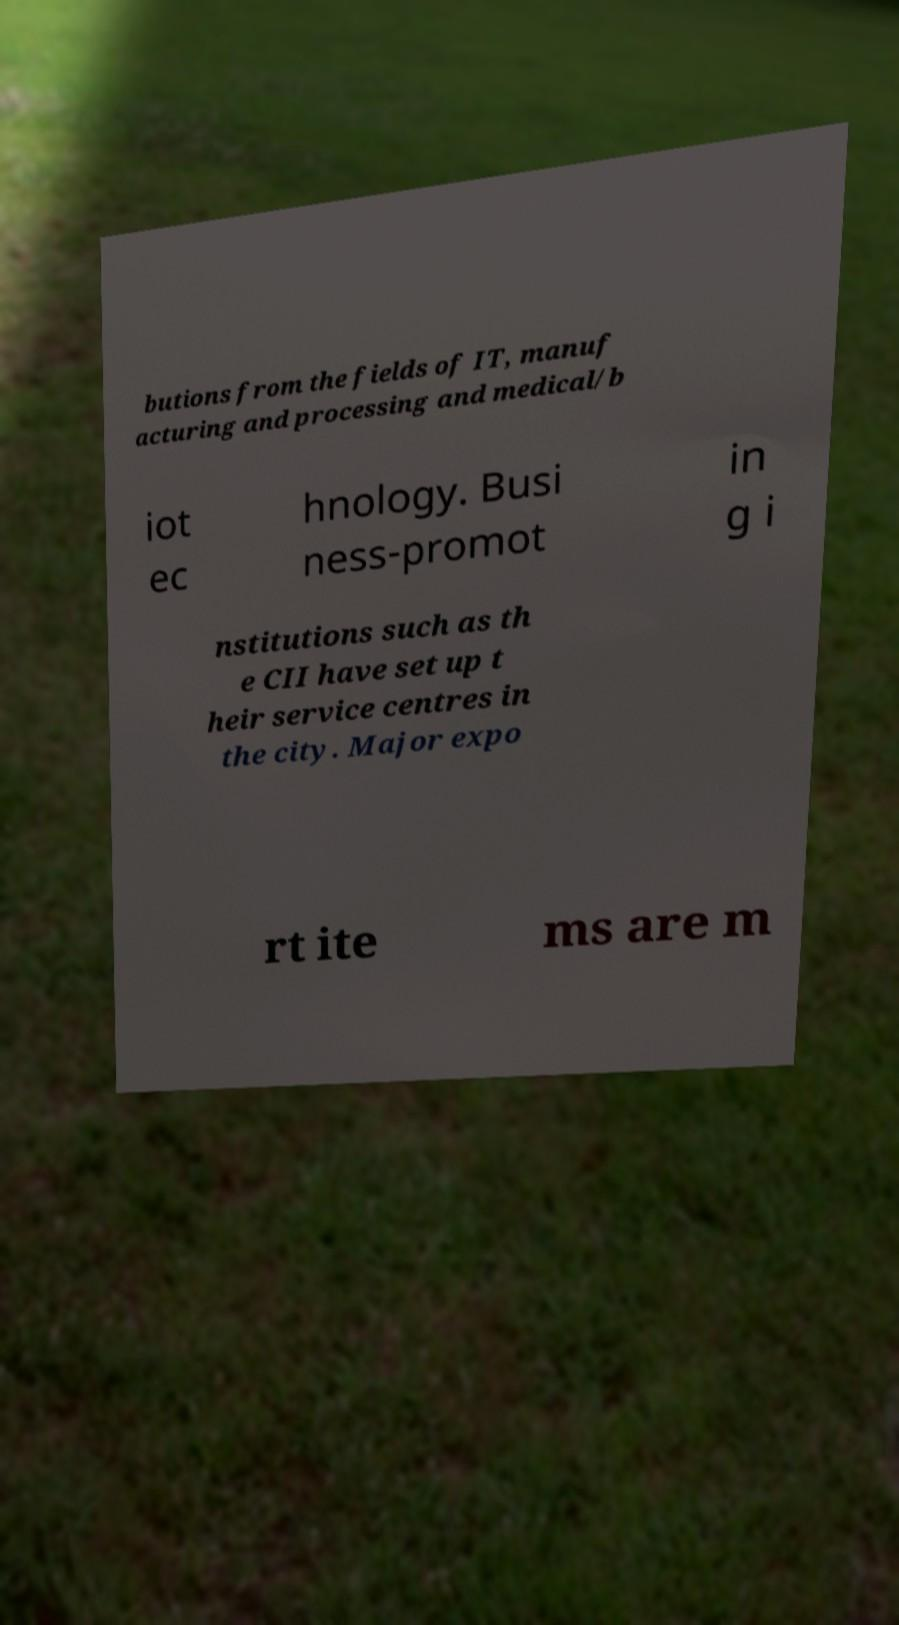I need the written content from this picture converted into text. Can you do that? butions from the fields of IT, manuf acturing and processing and medical/b iot ec hnology. Busi ness-promot in g i nstitutions such as th e CII have set up t heir service centres in the city. Major expo rt ite ms are m 